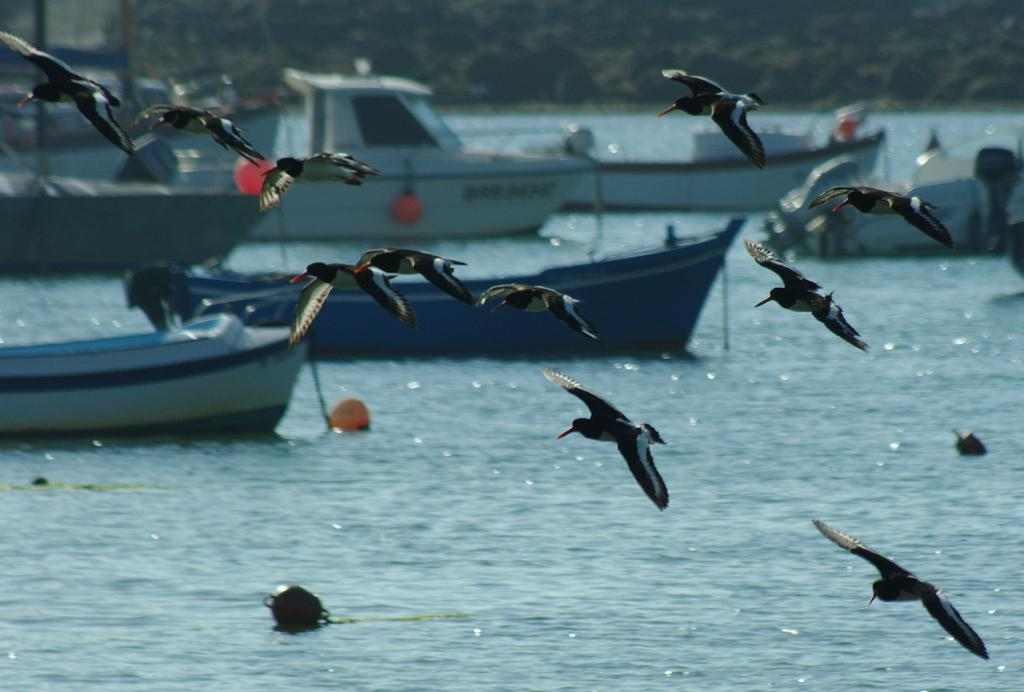What animals can be seen in the foreground of the image? There are birds in the foreground of the image. What are the birds doing in the image? The birds are flying in the image. What body of water is present in the image? There is a river in the image. What can be found in the river? There are boats in the river. What type of vegetation is visible in the background of the image? There are trees in the background of the image. Can you see any giraffes drinking from the river in the image? There are no giraffes present in the image. What type of spring is visible in the image? There is no spring present in the image. 